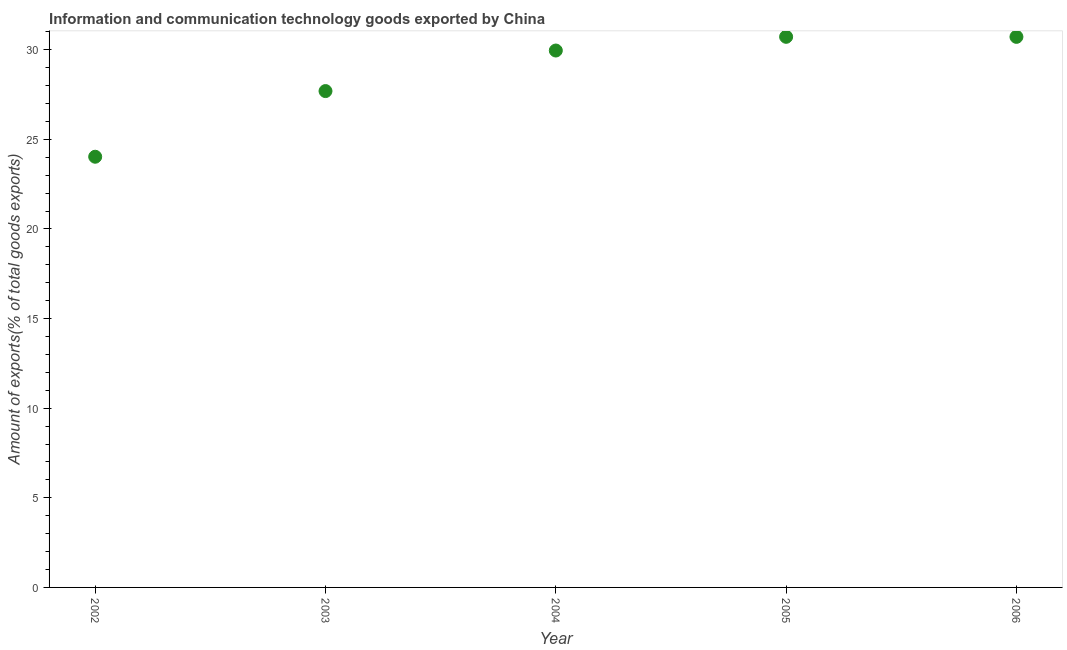What is the amount of ict goods exports in 2006?
Offer a terse response. 30.72. Across all years, what is the maximum amount of ict goods exports?
Your answer should be very brief. 30.72. Across all years, what is the minimum amount of ict goods exports?
Make the answer very short. 24.03. What is the sum of the amount of ict goods exports?
Your answer should be very brief. 143.12. What is the difference between the amount of ict goods exports in 2002 and 2004?
Offer a terse response. -5.93. What is the average amount of ict goods exports per year?
Your response must be concise. 28.62. What is the median amount of ict goods exports?
Provide a succinct answer. 29.96. In how many years, is the amount of ict goods exports greater than 3 %?
Give a very brief answer. 5. What is the ratio of the amount of ict goods exports in 2003 to that in 2005?
Give a very brief answer. 0.9. Is the amount of ict goods exports in 2004 less than that in 2005?
Keep it short and to the point. Yes. Is the difference between the amount of ict goods exports in 2003 and 2005 greater than the difference between any two years?
Give a very brief answer. No. What is the difference between the highest and the second highest amount of ict goods exports?
Keep it short and to the point. 0. Is the sum of the amount of ict goods exports in 2003 and 2005 greater than the maximum amount of ict goods exports across all years?
Your response must be concise. Yes. What is the difference between the highest and the lowest amount of ict goods exports?
Give a very brief answer. 6.69. In how many years, is the amount of ict goods exports greater than the average amount of ict goods exports taken over all years?
Offer a terse response. 3. How many dotlines are there?
Give a very brief answer. 1. What is the difference between two consecutive major ticks on the Y-axis?
Your answer should be compact. 5. Does the graph contain grids?
Give a very brief answer. No. What is the title of the graph?
Provide a succinct answer. Information and communication technology goods exported by China. What is the label or title of the X-axis?
Your response must be concise. Year. What is the label or title of the Y-axis?
Ensure brevity in your answer.  Amount of exports(% of total goods exports). What is the Amount of exports(% of total goods exports) in 2002?
Your answer should be very brief. 24.03. What is the Amount of exports(% of total goods exports) in 2003?
Make the answer very short. 27.69. What is the Amount of exports(% of total goods exports) in 2004?
Your response must be concise. 29.96. What is the Amount of exports(% of total goods exports) in 2005?
Offer a terse response. 30.72. What is the Amount of exports(% of total goods exports) in 2006?
Provide a short and direct response. 30.72. What is the difference between the Amount of exports(% of total goods exports) in 2002 and 2003?
Give a very brief answer. -3.66. What is the difference between the Amount of exports(% of total goods exports) in 2002 and 2004?
Your answer should be compact. -5.93. What is the difference between the Amount of exports(% of total goods exports) in 2002 and 2005?
Your answer should be compact. -6.69. What is the difference between the Amount of exports(% of total goods exports) in 2002 and 2006?
Provide a short and direct response. -6.69. What is the difference between the Amount of exports(% of total goods exports) in 2003 and 2004?
Ensure brevity in your answer.  -2.26. What is the difference between the Amount of exports(% of total goods exports) in 2003 and 2005?
Your answer should be very brief. -3.03. What is the difference between the Amount of exports(% of total goods exports) in 2003 and 2006?
Your answer should be very brief. -3.03. What is the difference between the Amount of exports(% of total goods exports) in 2004 and 2005?
Ensure brevity in your answer.  -0.76. What is the difference between the Amount of exports(% of total goods exports) in 2004 and 2006?
Your answer should be very brief. -0.76. What is the difference between the Amount of exports(% of total goods exports) in 2005 and 2006?
Ensure brevity in your answer.  0. What is the ratio of the Amount of exports(% of total goods exports) in 2002 to that in 2003?
Provide a short and direct response. 0.87. What is the ratio of the Amount of exports(% of total goods exports) in 2002 to that in 2004?
Provide a short and direct response. 0.8. What is the ratio of the Amount of exports(% of total goods exports) in 2002 to that in 2005?
Your answer should be very brief. 0.78. What is the ratio of the Amount of exports(% of total goods exports) in 2002 to that in 2006?
Provide a succinct answer. 0.78. What is the ratio of the Amount of exports(% of total goods exports) in 2003 to that in 2004?
Give a very brief answer. 0.92. What is the ratio of the Amount of exports(% of total goods exports) in 2003 to that in 2005?
Provide a succinct answer. 0.9. What is the ratio of the Amount of exports(% of total goods exports) in 2003 to that in 2006?
Give a very brief answer. 0.9. What is the ratio of the Amount of exports(% of total goods exports) in 2004 to that in 2006?
Keep it short and to the point. 0.97. What is the ratio of the Amount of exports(% of total goods exports) in 2005 to that in 2006?
Your answer should be very brief. 1. 